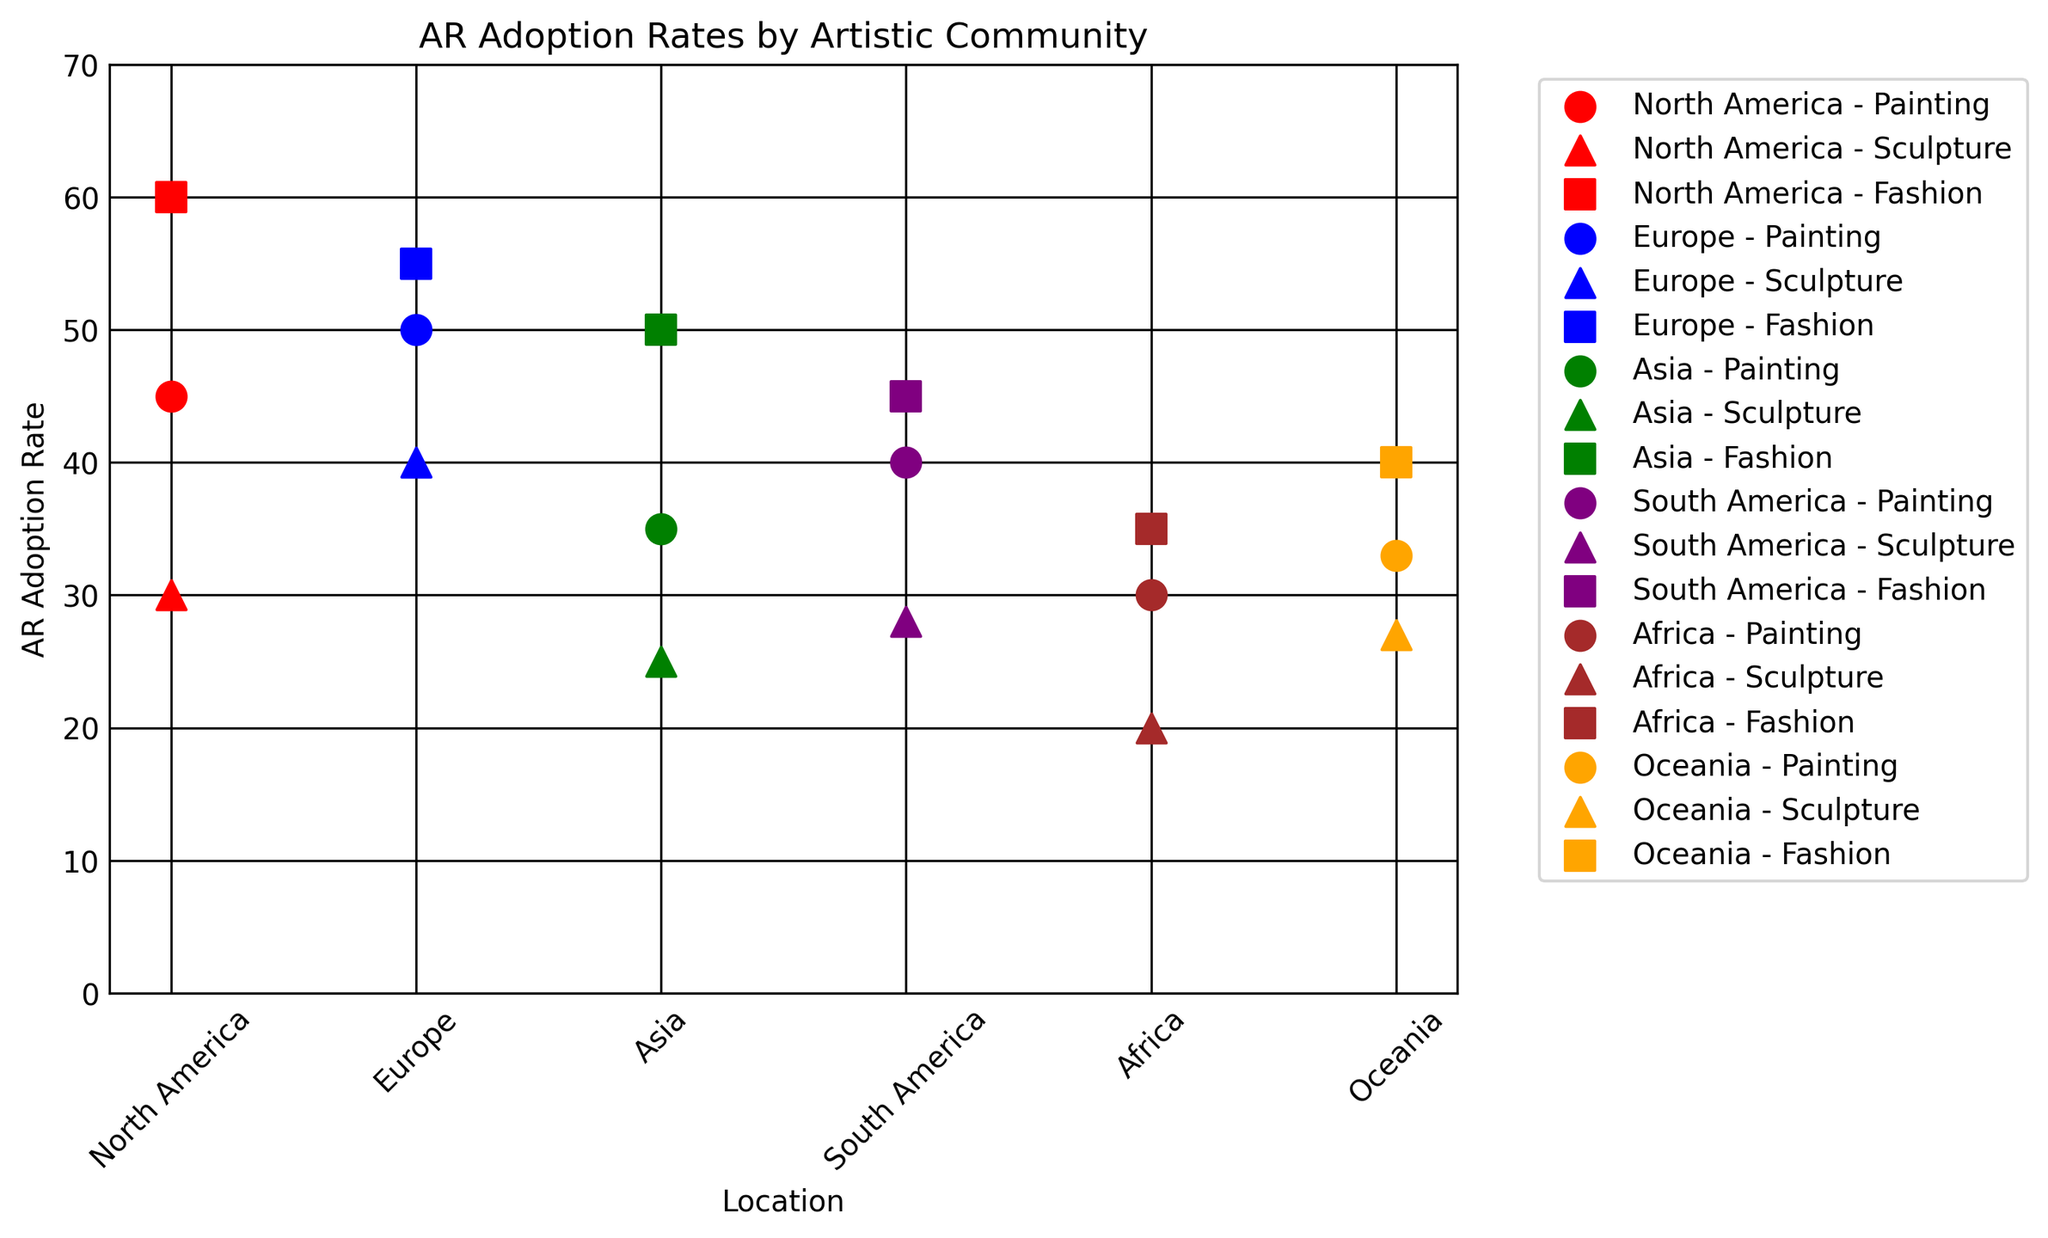What is the AR adoption rate for Fashion in North America? Look for the marker for Fashion (square marker) in the color representing North America (red). The Y-axis value for this marker provides the AR adoption rate.
Answer: 60 Which art form in Europe has the lowest AR adoption rate? Compare the Y-axis values for the markers representing different art forms (Painting, Sculpture, and Fashion) in the color representing Europe (blue). The lowest Y-axis value corresponds to Sculpture.
Answer: Sculpture How does the AR adoption rate for Painting in Asia compare to that in South America? Locate the markers for Painting (circular marker) in the colors representing Asia (green) and South America (purple). The Y-axis values show that the rate for Asia is 35 and for South America is 40.
Answer: Asia: 35, South America: 40 What is the average AR adoption rate for Sculpture across all locations? Identify the markers for Sculpture (triangular marker) in each color and note their Y-axis values: 30 (North America), 40 (Europe), 25 (Asia), 28 (South America), 20 (Africa), 27 (Oceania). Sum these values and divide by the number of locations (6). (30+40+25+28+20+27) / 6 = 28.33.
Answer: 28.33 Which location-art form pair has the highest AR adoption rate? Compare the Y-axis values for all markers. The highest value is 60 for Fashion in North America (red square marker).
Answer: Fashion in North America What's the difference in AR adoption rates between Fashion in Africa and Painting in Oceania? Locate the markers for Fashion in Africa (brown square marker) and Painting in Oceania (orange circular marker) and note their Y-axis values: 35 for Africa and 33 for Oceania. Calculate the difference: 35 - 33.
Answer: 2 What is the sum of AR adoption rates for Sculpture in North America and Fashion in Europe? Identify the markers for Sculpture in North America (red triangular marker) and Fashion in Europe (blue square marker), noting their Y-axis values: 30 for North America and 55 for Europe. Calculate the sum: 30 + 55.
Answer: 85 Which location has the most balanced AR adoption rates across all art forms? Look at the spread of Y-axis values for each location. For example, in North America (red markers), the rates are 45 (Painting), 30 (Sculpture), and 60 (Fashion), showing a wider spread compared to, for example, Oceania (orange markers) with 33 (Painting), 27 (Sculpture), and 40 (Fashion).
Answer: Oceania 